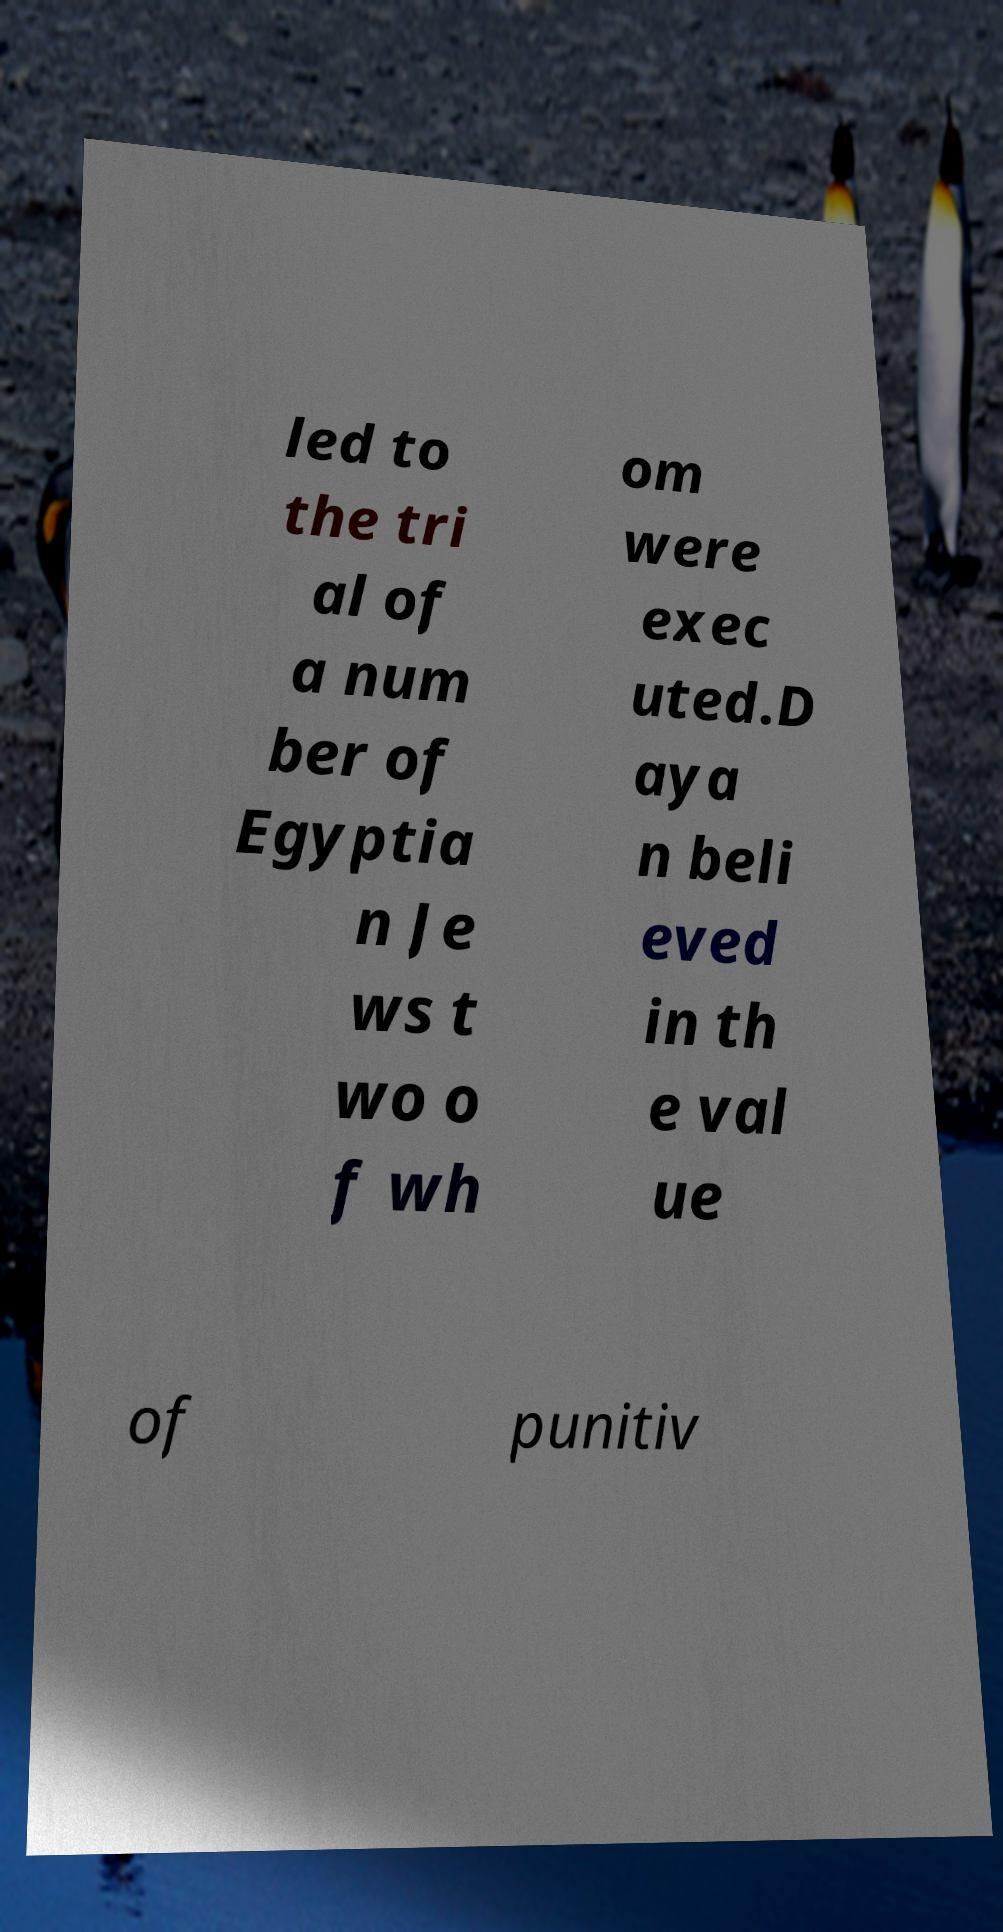Please identify and transcribe the text found in this image. led to the tri al of a num ber of Egyptia n Je ws t wo o f wh om were exec uted.D aya n beli eved in th e val ue of punitiv 